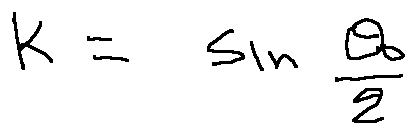Convert formula to latex. <formula><loc_0><loc_0><loc_500><loc_500>k = \sin \frac { \theta _ { 0 } } { 2 }</formula> 